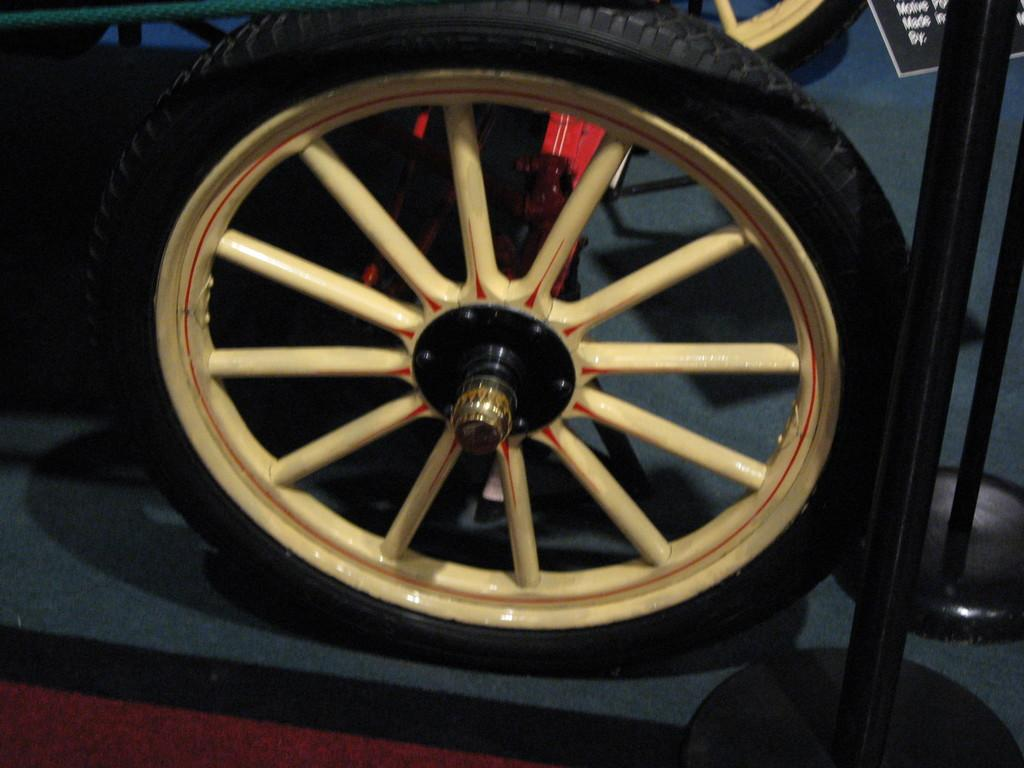What type of object or feature is represented by the wheels in the image? The wheels in the image suggest the presence of a vehicle or a rotating mechanism. What committee is responsible for the maintenance of the wheels in the image? There is no committee mentioned or implied in the image, as it only shows wheels without any context or additional information. 